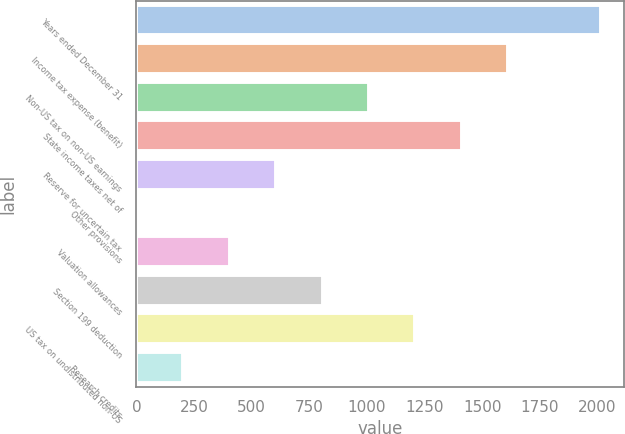<chart> <loc_0><loc_0><loc_500><loc_500><bar_chart><fcel>Years ended December 31<fcel>Income tax expense (benefit)<fcel>Non-US tax on non-US earnings<fcel>State income taxes net of<fcel>Reserve for uncertain tax<fcel>Other provisions<fcel>Valuation allowances<fcel>Section 199 deduction<fcel>US tax on undistributed non-US<fcel>Research credits<nl><fcel>2016<fcel>1613.2<fcel>1009<fcel>1411.8<fcel>606.2<fcel>2<fcel>404.8<fcel>807.6<fcel>1210.4<fcel>203.4<nl></chart> 